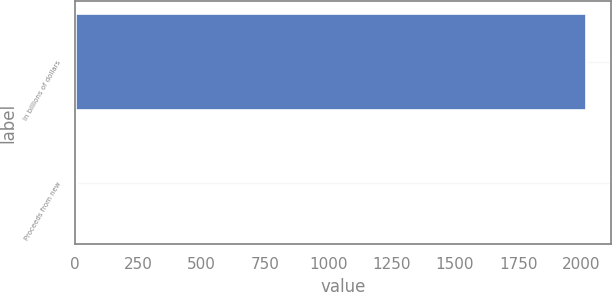<chart> <loc_0><loc_0><loc_500><loc_500><bar_chart><fcel>In billions of dollars<fcel>Proceeds from new<nl><fcel>2016<fcel>5<nl></chart> 